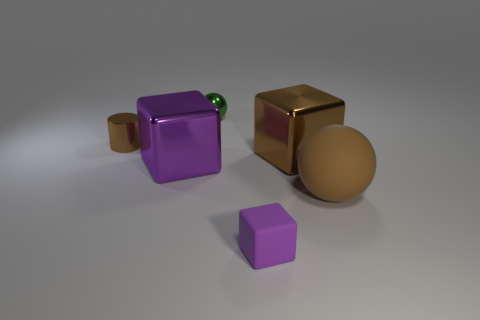Add 2 red rubber cubes. How many objects exist? 8 Subtract 1 cubes. How many cubes are left? 2 Subtract all spheres. How many objects are left? 4 Subtract all small cyan cylinders. Subtract all small matte blocks. How many objects are left? 5 Add 5 large spheres. How many large spheres are left? 6 Add 6 rubber balls. How many rubber balls exist? 7 Subtract 1 brown cylinders. How many objects are left? 5 